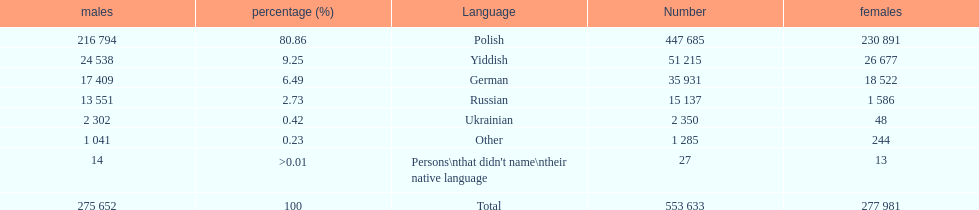How many people didn't name their native language? 27. 